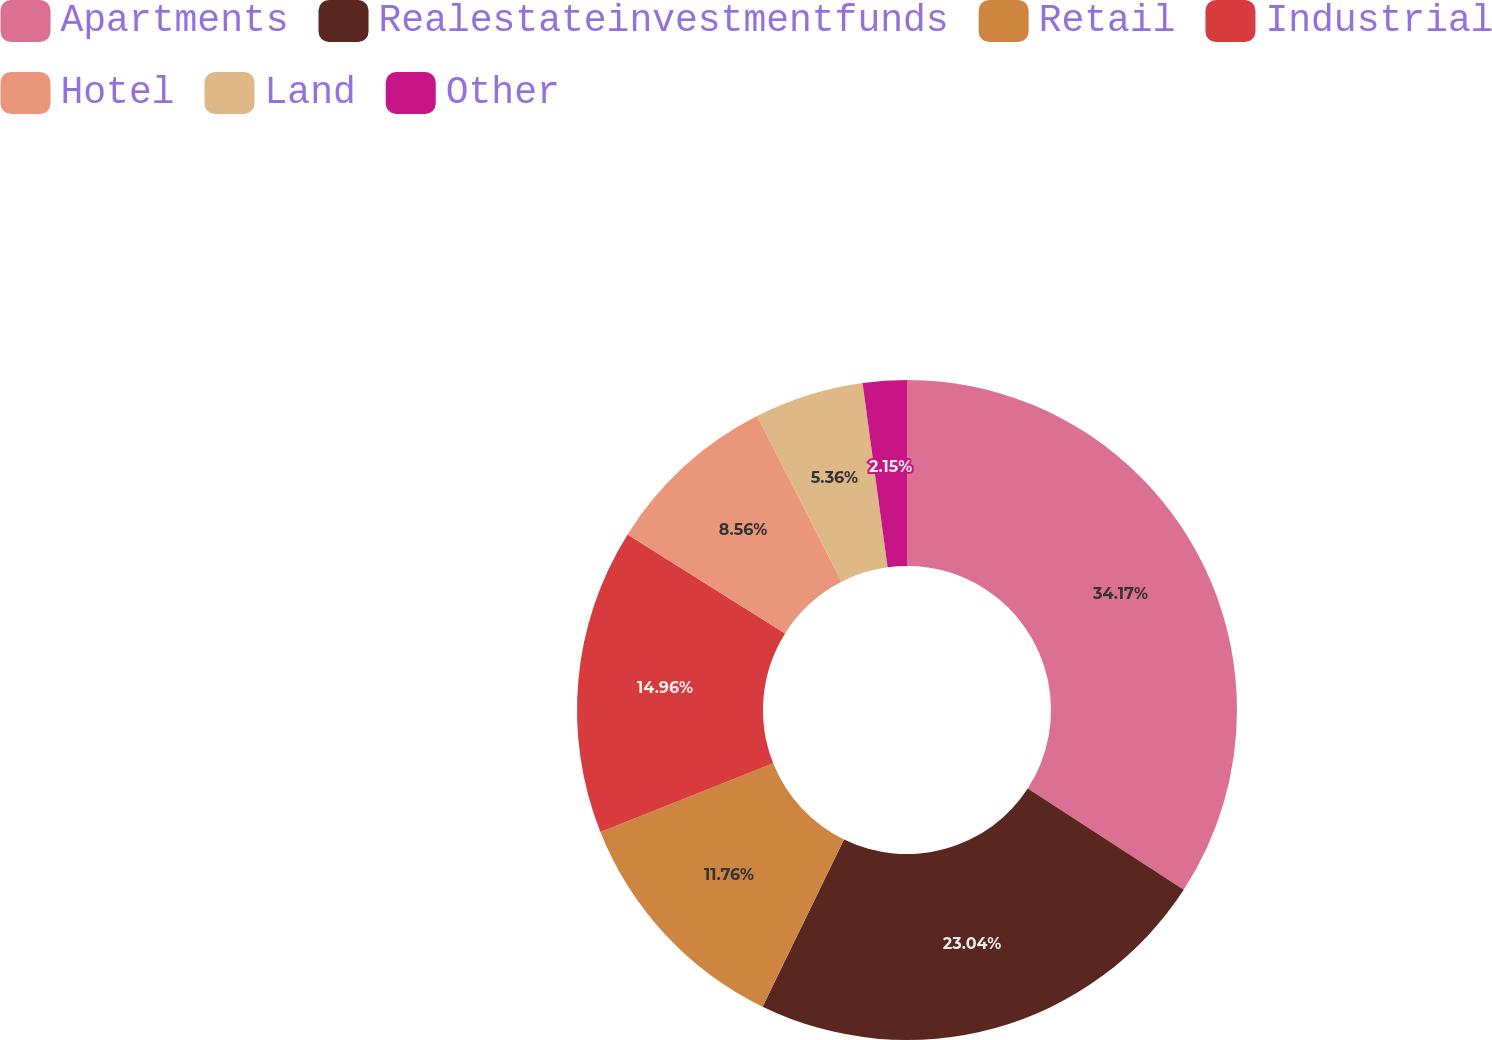Convert chart to OTSL. <chart><loc_0><loc_0><loc_500><loc_500><pie_chart><fcel>Apartments<fcel>Realestateinvestmentfunds<fcel>Retail<fcel>Industrial<fcel>Hotel<fcel>Land<fcel>Other<nl><fcel>34.17%<fcel>23.04%<fcel>11.76%<fcel>14.96%<fcel>8.56%<fcel>5.36%<fcel>2.15%<nl></chart> 